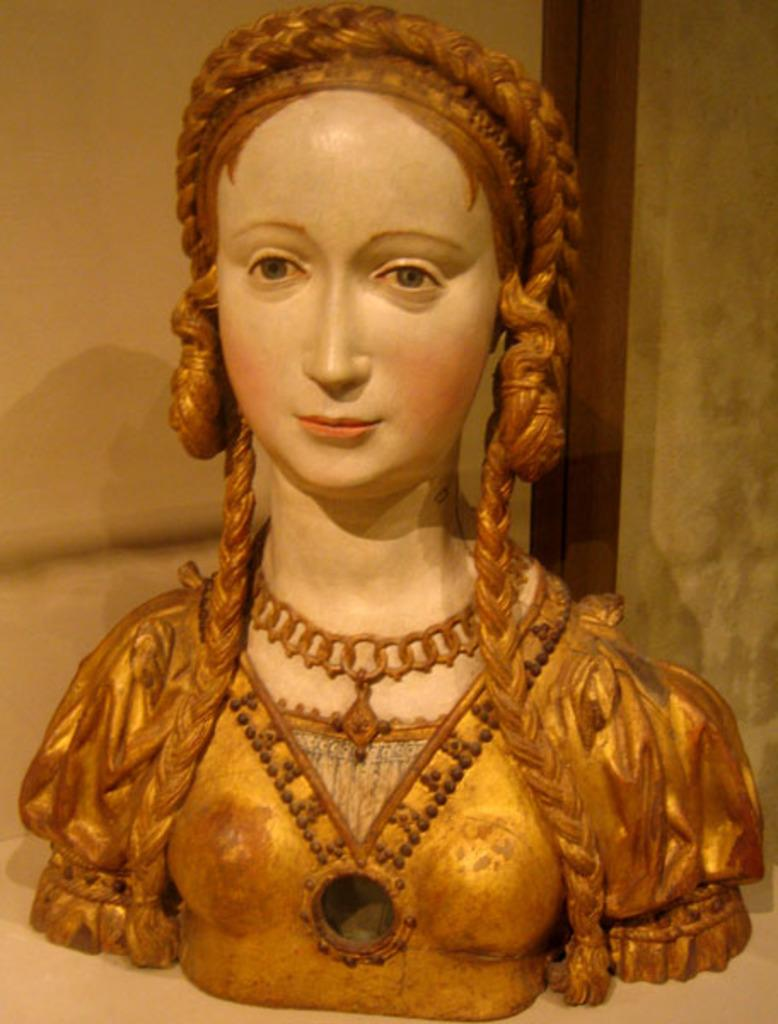What is the main subject of the image? There is a sculpture in the image. Can you describe the sculpture? The sculpture is of a lady. What color is the sculpture? The sculpture is painted in gold. Can you see any dust on the sculpture in the image? There is no mention of dust in the image, and therefore it cannot be determined if there is any dust present. 